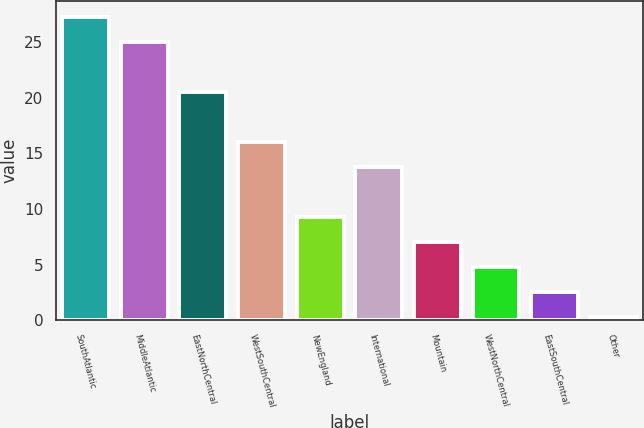<chart> <loc_0><loc_0><loc_500><loc_500><bar_chart><fcel>SouthAtlantic<fcel>MiddleAtlantic<fcel>EastNorthCentral<fcel>WestSouthCentral<fcel>NewEngland<fcel>International<fcel>Mountain<fcel>WestNorthCentral<fcel>EastSouthCentral<fcel>Other<nl><fcel>27.3<fcel>25.05<fcel>20.55<fcel>16.05<fcel>9.3<fcel>13.8<fcel>7.05<fcel>4.8<fcel>2.55<fcel>0.3<nl></chart> 